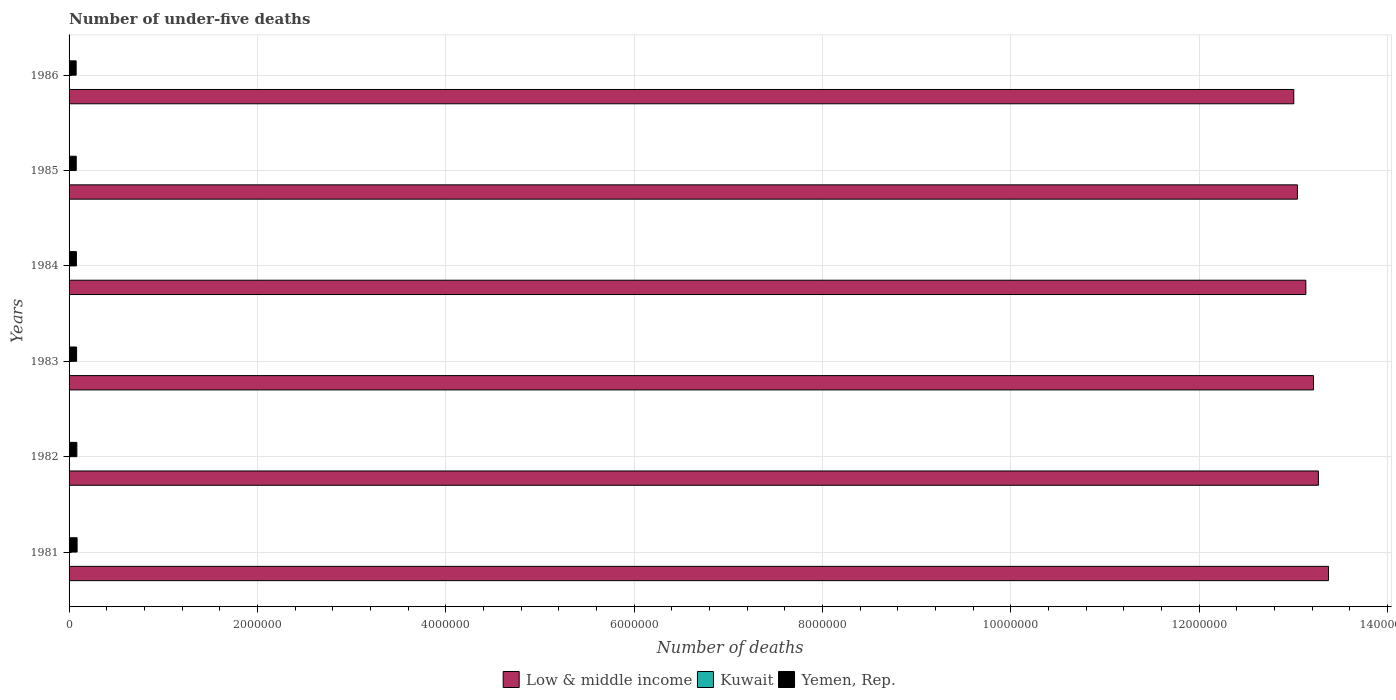How many groups of bars are there?
Make the answer very short. 6. Are the number of bars per tick equal to the number of legend labels?
Offer a terse response. Yes. How many bars are there on the 2nd tick from the top?
Offer a very short reply. 3. How many bars are there on the 1st tick from the bottom?
Your answer should be very brief. 3. In how many cases, is the number of bars for a given year not equal to the number of legend labels?
Your response must be concise. 0. What is the number of under-five deaths in Low & middle income in 1982?
Offer a very short reply. 1.33e+07. Across all years, what is the maximum number of under-five deaths in Kuwait?
Keep it short and to the point. 1573. Across all years, what is the minimum number of under-five deaths in Kuwait?
Give a very brief answer. 1160. What is the total number of under-five deaths in Yemen, Rep. in the graph?
Offer a very short reply. 4.77e+05. What is the difference between the number of under-five deaths in Low & middle income in 1983 and that in 1984?
Your answer should be compact. 8.14e+04. What is the difference between the number of under-five deaths in Yemen, Rep. in 1986 and the number of under-five deaths in Kuwait in 1984?
Provide a short and direct response. 7.38e+04. What is the average number of under-five deaths in Yemen, Rep. per year?
Keep it short and to the point. 7.95e+04. In the year 1983, what is the difference between the number of under-five deaths in Yemen, Rep. and number of under-five deaths in Low & middle income?
Your answer should be very brief. -1.31e+07. In how many years, is the number of under-five deaths in Kuwait greater than 2400000 ?
Your answer should be very brief. 0. What is the ratio of the number of under-five deaths in Kuwait in 1983 to that in 1985?
Offer a terse response. 1.13. Is the difference between the number of under-five deaths in Yemen, Rep. in 1982 and 1985 greater than the difference between the number of under-five deaths in Low & middle income in 1982 and 1985?
Your answer should be very brief. No. What is the difference between the highest and the second highest number of under-five deaths in Low & middle income?
Make the answer very short. 1.08e+05. What is the difference between the highest and the lowest number of under-five deaths in Low & middle income?
Keep it short and to the point. 3.69e+05. In how many years, is the number of under-five deaths in Kuwait greater than the average number of under-five deaths in Kuwait taken over all years?
Provide a short and direct response. 3. Is the sum of the number of under-five deaths in Kuwait in 1981 and 1982 greater than the maximum number of under-five deaths in Yemen, Rep. across all years?
Make the answer very short. No. What does the 3rd bar from the top in 1984 represents?
Your response must be concise. Low & middle income. What does the 1st bar from the bottom in 1981 represents?
Provide a short and direct response. Low & middle income. Is it the case that in every year, the sum of the number of under-five deaths in Low & middle income and number of under-five deaths in Kuwait is greater than the number of under-five deaths in Yemen, Rep.?
Make the answer very short. Yes. How many bars are there?
Your answer should be very brief. 18. Are all the bars in the graph horizontal?
Keep it short and to the point. Yes. How many years are there in the graph?
Your answer should be compact. 6. What is the difference between two consecutive major ticks on the X-axis?
Your answer should be compact. 2.00e+06. Are the values on the major ticks of X-axis written in scientific E-notation?
Your answer should be very brief. No. Does the graph contain any zero values?
Offer a very short reply. No. Where does the legend appear in the graph?
Keep it short and to the point. Bottom center. How many legend labels are there?
Provide a succinct answer. 3. What is the title of the graph?
Ensure brevity in your answer.  Number of under-five deaths. What is the label or title of the X-axis?
Provide a short and direct response. Number of deaths. What is the label or title of the Y-axis?
Give a very brief answer. Years. What is the Number of deaths in Low & middle income in 1981?
Ensure brevity in your answer.  1.34e+07. What is the Number of deaths in Kuwait in 1981?
Your answer should be very brief. 1573. What is the Number of deaths in Yemen, Rep. in 1981?
Provide a short and direct response. 8.51e+04. What is the Number of deaths of Low & middle income in 1982?
Provide a succinct answer. 1.33e+07. What is the Number of deaths in Kuwait in 1982?
Offer a very short reply. 1484. What is the Number of deaths of Yemen, Rep. in 1982?
Make the answer very short. 8.27e+04. What is the Number of deaths in Low & middle income in 1983?
Keep it short and to the point. 1.32e+07. What is the Number of deaths of Kuwait in 1983?
Your answer should be very brief. 1404. What is the Number of deaths in Yemen, Rep. in 1983?
Offer a terse response. 8.01e+04. What is the Number of deaths in Low & middle income in 1984?
Your answer should be very brief. 1.31e+07. What is the Number of deaths of Kuwait in 1984?
Offer a very short reply. 1323. What is the Number of deaths in Yemen, Rep. in 1984?
Provide a short and direct response. 7.79e+04. What is the Number of deaths in Low & middle income in 1985?
Offer a very short reply. 1.30e+07. What is the Number of deaths in Kuwait in 1985?
Provide a succinct answer. 1239. What is the Number of deaths in Yemen, Rep. in 1985?
Your response must be concise. 7.63e+04. What is the Number of deaths of Low & middle income in 1986?
Provide a short and direct response. 1.30e+07. What is the Number of deaths of Kuwait in 1986?
Give a very brief answer. 1160. What is the Number of deaths in Yemen, Rep. in 1986?
Make the answer very short. 7.51e+04. Across all years, what is the maximum Number of deaths in Low & middle income?
Offer a terse response. 1.34e+07. Across all years, what is the maximum Number of deaths of Kuwait?
Your answer should be compact. 1573. Across all years, what is the maximum Number of deaths of Yemen, Rep.?
Your response must be concise. 8.51e+04. Across all years, what is the minimum Number of deaths of Low & middle income?
Provide a short and direct response. 1.30e+07. Across all years, what is the minimum Number of deaths in Kuwait?
Make the answer very short. 1160. Across all years, what is the minimum Number of deaths in Yemen, Rep.?
Provide a short and direct response. 7.51e+04. What is the total Number of deaths of Low & middle income in the graph?
Your answer should be very brief. 7.90e+07. What is the total Number of deaths in Kuwait in the graph?
Give a very brief answer. 8183. What is the total Number of deaths in Yemen, Rep. in the graph?
Give a very brief answer. 4.77e+05. What is the difference between the Number of deaths of Low & middle income in 1981 and that in 1982?
Ensure brevity in your answer.  1.08e+05. What is the difference between the Number of deaths in Kuwait in 1981 and that in 1982?
Your response must be concise. 89. What is the difference between the Number of deaths of Yemen, Rep. in 1981 and that in 1982?
Give a very brief answer. 2482. What is the difference between the Number of deaths of Low & middle income in 1981 and that in 1983?
Make the answer very short. 1.59e+05. What is the difference between the Number of deaths in Kuwait in 1981 and that in 1983?
Offer a terse response. 169. What is the difference between the Number of deaths of Yemen, Rep. in 1981 and that in 1983?
Make the answer very short. 5046. What is the difference between the Number of deaths in Low & middle income in 1981 and that in 1984?
Make the answer very short. 2.41e+05. What is the difference between the Number of deaths in Kuwait in 1981 and that in 1984?
Your answer should be very brief. 250. What is the difference between the Number of deaths of Yemen, Rep. in 1981 and that in 1984?
Your response must be concise. 7245. What is the difference between the Number of deaths in Low & middle income in 1981 and that in 1985?
Offer a very short reply. 3.30e+05. What is the difference between the Number of deaths in Kuwait in 1981 and that in 1985?
Provide a succinct answer. 334. What is the difference between the Number of deaths in Yemen, Rep. in 1981 and that in 1985?
Make the answer very short. 8877. What is the difference between the Number of deaths of Low & middle income in 1981 and that in 1986?
Offer a very short reply. 3.69e+05. What is the difference between the Number of deaths of Kuwait in 1981 and that in 1986?
Your answer should be very brief. 413. What is the difference between the Number of deaths of Yemen, Rep. in 1981 and that in 1986?
Ensure brevity in your answer.  1.00e+04. What is the difference between the Number of deaths in Low & middle income in 1982 and that in 1983?
Ensure brevity in your answer.  5.17e+04. What is the difference between the Number of deaths of Yemen, Rep. in 1982 and that in 1983?
Your answer should be compact. 2564. What is the difference between the Number of deaths of Low & middle income in 1982 and that in 1984?
Offer a very short reply. 1.33e+05. What is the difference between the Number of deaths in Kuwait in 1982 and that in 1984?
Your answer should be compact. 161. What is the difference between the Number of deaths in Yemen, Rep. in 1982 and that in 1984?
Provide a short and direct response. 4763. What is the difference between the Number of deaths of Low & middle income in 1982 and that in 1985?
Offer a terse response. 2.23e+05. What is the difference between the Number of deaths in Kuwait in 1982 and that in 1985?
Provide a short and direct response. 245. What is the difference between the Number of deaths of Yemen, Rep. in 1982 and that in 1985?
Offer a terse response. 6395. What is the difference between the Number of deaths in Low & middle income in 1982 and that in 1986?
Give a very brief answer. 2.61e+05. What is the difference between the Number of deaths in Kuwait in 1982 and that in 1986?
Your response must be concise. 324. What is the difference between the Number of deaths in Yemen, Rep. in 1982 and that in 1986?
Ensure brevity in your answer.  7550. What is the difference between the Number of deaths in Low & middle income in 1983 and that in 1984?
Offer a terse response. 8.14e+04. What is the difference between the Number of deaths in Yemen, Rep. in 1983 and that in 1984?
Your answer should be very brief. 2199. What is the difference between the Number of deaths of Low & middle income in 1983 and that in 1985?
Your answer should be very brief. 1.71e+05. What is the difference between the Number of deaths in Kuwait in 1983 and that in 1985?
Give a very brief answer. 165. What is the difference between the Number of deaths in Yemen, Rep. in 1983 and that in 1985?
Provide a short and direct response. 3831. What is the difference between the Number of deaths in Low & middle income in 1983 and that in 1986?
Your answer should be compact. 2.09e+05. What is the difference between the Number of deaths of Kuwait in 1983 and that in 1986?
Offer a terse response. 244. What is the difference between the Number of deaths in Yemen, Rep. in 1983 and that in 1986?
Keep it short and to the point. 4986. What is the difference between the Number of deaths of Low & middle income in 1984 and that in 1985?
Keep it short and to the point. 8.95e+04. What is the difference between the Number of deaths in Yemen, Rep. in 1984 and that in 1985?
Give a very brief answer. 1632. What is the difference between the Number of deaths of Low & middle income in 1984 and that in 1986?
Provide a succinct answer. 1.28e+05. What is the difference between the Number of deaths of Kuwait in 1984 and that in 1986?
Provide a succinct answer. 163. What is the difference between the Number of deaths of Yemen, Rep. in 1984 and that in 1986?
Make the answer very short. 2787. What is the difference between the Number of deaths in Low & middle income in 1985 and that in 1986?
Your answer should be very brief. 3.86e+04. What is the difference between the Number of deaths in Kuwait in 1985 and that in 1986?
Provide a succinct answer. 79. What is the difference between the Number of deaths in Yemen, Rep. in 1985 and that in 1986?
Give a very brief answer. 1155. What is the difference between the Number of deaths in Low & middle income in 1981 and the Number of deaths in Kuwait in 1982?
Your answer should be very brief. 1.34e+07. What is the difference between the Number of deaths in Low & middle income in 1981 and the Number of deaths in Yemen, Rep. in 1982?
Offer a very short reply. 1.33e+07. What is the difference between the Number of deaths of Kuwait in 1981 and the Number of deaths of Yemen, Rep. in 1982?
Offer a terse response. -8.11e+04. What is the difference between the Number of deaths of Low & middle income in 1981 and the Number of deaths of Kuwait in 1983?
Make the answer very short. 1.34e+07. What is the difference between the Number of deaths of Low & middle income in 1981 and the Number of deaths of Yemen, Rep. in 1983?
Keep it short and to the point. 1.33e+07. What is the difference between the Number of deaths in Kuwait in 1981 and the Number of deaths in Yemen, Rep. in 1983?
Ensure brevity in your answer.  -7.85e+04. What is the difference between the Number of deaths of Low & middle income in 1981 and the Number of deaths of Kuwait in 1984?
Keep it short and to the point. 1.34e+07. What is the difference between the Number of deaths in Low & middle income in 1981 and the Number of deaths in Yemen, Rep. in 1984?
Give a very brief answer. 1.33e+07. What is the difference between the Number of deaths of Kuwait in 1981 and the Number of deaths of Yemen, Rep. in 1984?
Your response must be concise. -7.63e+04. What is the difference between the Number of deaths in Low & middle income in 1981 and the Number of deaths in Kuwait in 1985?
Your answer should be very brief. 1.34e+07. What is the difference between the Number of deaths of Low & middle income in 1981 and the Number of deaths of Yemen, Rep. in 1985?
Your answer should be compact. 1.33e+07. What is the difference between the Number of deaths in Kuwait in 1981 and the Number of deaths in Yemen, Rep. in 1985?
Provide a succinct answer. -7.47e+04. What is the difference between the Number of deaths of Low & middle income in 1981 and the Number of deaths of Kuwait in 1986?
Give a very brief answer. 1.34e+07. What is the difference between the Number of deaths in Low & middle income in 1981 and the Number of deaths in Yemen, Rep. in 1986?
Ensure brevity in your answer.  1.33e+07. What is the difference between the Number of deaths of Kuwait in 1981 and the Number of deaths of Yemen, Rep. in 1986?
Your answer should be compact. -7.35e+04. What is the difference between the Number of deaths of Low & middle income in 1982 and the Number of deaths of Kuwait in 1983?
Your response must be concise. 1.33e+07. What is the difference between the Number of deaths of Low & middle income in 1982 and the Number of deaths of Yemen, Rep. in 1983?
Provide a succinct answer. 1.32e+07. What is the difference between the Number of deaths of Kuwait in 1982 and the Number of deaths of Yemen, Rep. in 1983?
Your answer should be compact. -7.86e+04. What is the difference between the Number of deaths in Low & middle income in 1982 and the Number of deaths in Kuwait in 1984?
Your answer should be compact. 1.33e+07. What is the difference between the Number of deaths in Low & middle income in 1982 and the Number of deaths in Yemen, Rep. in 1984?
Offer a terse response. 1.32e+07. What is the difference between the Number of deaths in Kuwait in 1982 and the Number of deaths in Yemen, Rep. in 1984?
Ensure brevity in your answer.  -7.64e+04. What is the difference between the Number of deaths of Low & middle income in 1982 and the Number of deaths of Kuwait in 1985?
Keep it short and to the point. 1.33e+07. What is the difference between the Number of deaths in Low & middle income in 1982 and the Number of deaths in Yemen, Rep. in 1985?
Offer a very short reply. 1.32e+07. What is the difference between the Number of deaths in Kuwait in 1982 and the Number of deaths in Yemen, Rep. in 1985?
Your answer should be very brief. -7.48e+04. What is the difference between the Number of deaths of Low & middle income in 1982 and the Number of deaths of Kuwait in 1986?
Your response must be concise. 1.33e+07. What is the difference between the Number of deaths in Low & middle income in 1982 and the Number of deaths in Yemen, Rep. in 1986?
Provide a succinct answer. 1.32e+07. What is the difference between the Number of deaths in Kuwait in 1982 and the Number of deaths in Yemen, Rep. in 1986?
Your answer should be compact. -7.36e+04. What is the difference between the Number of deaths of Low & middle income in 1983 and the Number of deaths of Kuwait in 1984?
Provide a succinct answer. 1.32e+07. What is the difference between the Number of deaths of Low & middle income in 1983 and the Number of deaths of Yemen, Rep. in 1984?
Your answer should be very brief. 1.31e+07. What is the difference between the Number of deaths of Kuwait in 1983 and the Number of deaths of Yemen, Rep. in 1984?
Make the answer very short. -7.65e+04. What is the difference between the Number of deaths in Low & middle income in 1983 and the Number of deaths in Kuwait in 1985?
Your response must be concise. 1.32e+07. What is the difference between the Number of deaths of Low & middle income in 1983 and the Number of deaths of Yemen, Rep. in 1985?
Make the answer very short. 1.31e+07. What is the difference between the Number of deaths of Kuwait in 1983 and the Number of deaths of Yemen, Rep. in 1985?
Ensure brevity in your answer.  -7.49e+04. What is the difference between the Number of deaths of Low & middle income in 1983 and the Number of deaths of Kuwait in 1986?
Your answer should be very brief. 1.32e+07. What is the difference between the Number of deaths of Low & middle income in 1983 and the Number of deaths of Yemen, Rep. in 1986?
Give a very brief answer. 1.31e+07. What is the difference between the Number of deaths of Kuwait in 1983 and the Number of deaths of Yemen, Rep. in 1986?
Make the answer very short. -7.37e+04. What is the difference between the Number of deaths in Low & middle income in 1984 and the Number of deaths in Kuwait in 1985?
Give a very brief answer. 1.31e+07. What is the difference between the Number of deaths in Low & middle income in 1984 and the Number of deaths in Yemen, Rep. in 1985?
Provide a short and direct response. 1.31e+07. What is the difference between the Number of deaths of Kuwait in 1984 and the Number of deaths of Yemen, Rep. in 1985?
Make the answer very short. -7.49e+04. What is the difference between the Number of deaths in Low & middle income in 1984 and the Number of deaths in Kuwait in 1986?
Your answer should be compact. 1.31e+07. What is the difference between the Number of deaths in Low & middle income in 1984 and the Number of deaths in Yemen, Rep. in 1986?
Offer a very short reply. 1.31e+07. What is the difference between the Number of deaths in Kuwait in 1984 and the Number of deaths in Yemen, Rep. in 1986?
Ensure brevity in your answer.  -7.38e+04. What is the difference between the Number of deaths in Low & middle income in 1985 and the Number of deaths in Kuwait in 1986?
Ensure brevity in your answer.  1.30e+07. What is the difference between the Number of deaths in Low & middle income in 1985 and the Number of deaths in Yemen, Rep. in 1986?
Ensure brevity in your answer.  1.30e+07. What is the difference between the Number of deaths of Kuwait in 1985 and the Number of deaths of Yemen, Rep. in 1986?
Ensure brevity in your answer.  -7.39e+04. What is the average Number of deaths in Low & middle income per year?
Your answer should be compact. 1.32e+07. What is the average Number of deaths of Kuwait per year?
Your answer should be very brief. 1363.83. What is the average Number of deaths in Yemen, Rep. per year?
Make the answer very short. 7.95e+04. In the year 1981, what is the difference between the Number of deaths of Low & middle income and Number of deaths of Kuwait?
Offer a terse response. 1.34e+07. In the year 1981, what is the difference between the Number of deaths in Low & middle income and Number of deaths in Yemen, Rep.?
Your answer should be very brief. 1.33e+07. In the year 1981, what is the difference between the Number of deaths in Kuwait and Number of deaths in Yemen, Rep.?
Provide a short and direct response. -8.36e+04. In the year 1982, what is the difference between the Number of deaths of Low & middle income and Number of deaths of Kuwait?
Your answer should be very brief. 1.33e+07. In the year 1982, what is the difference between the Number of deaths of Low & middle income and Number of deaths of Yemen, Rep.?
Ensure brevity in your answer.  1.32e+07. In the year 1982, what is the difference between the Number of deaths in Kuwait and Number of deaths in Yemen, Rep.?
Provide a succinct answer. -8.12e+04. In the year 1983, what is the difference between the Number of deaths in Low & middle income and Number of deaths in Kuwait?
Your response must be concise. 1.32e+07. In the year 1983, what is the difference between the Number of deaths in Low & middle income and Number of deaths in Yemen, Rep.?
Your response must be concise. 1.31e+07. In the year 1983, what is the difference between the Number of deaths of Kuwait and Number of deaths of Yemen, Rep.?
Ensure brevity in your answer.  -7.87e+04. In the year 1984, what is the difference between the Number of deaths of Low & middle income and Number of deaths of Kuwait?
Make the answer very short. 1.31e+07. In the year 1984, what is the difference between the Number of deaths of Low & middle income and Number of deaths of Yemen, Rep.?
Offer a terse response. 1.31e+07. In the year 1984, what is the difference between the Number of deaths of Kuwait and Number of deaths of Yemen, Rep.?
Offer a terse response. -7.66e+04. In the year 1985, what is the difference between the Number of deaths of Low & middle income and Number of deaths of Kuwait?
Your answer should be very brief. 1.30e+07. In the year 1985, what is the difference between the Number of deaths of Low & middle income and Number of deaths of Yemen, Rep.?
Ensure brevity in your answer.  1.30e+07. In the year 1985, what is the difference between the Number of deaths in Kuwait and Number of deaths in Yemen, Rep.?
Provide a succinct answer. -7.50e+04. In the year 1986, what is the difference between the Number of deaths in Low & middle income and Number of deaths in Kuwait?
Provide a short and direct response. 1.30e+07. In the year 1986, what is the difference between the Number of deaths of Low & middle income and Number of deaths of Yemen, Rep.?
Your response must be concise. 1.29e+07. In the year 1986, what is the difference between the Number of deaths in Kuwait and Number of deaths in Yemen, Rep.?
Provide a succinct answer. -7.39e+04. What is the ratio of the Number of deaths in Kuwait in 1981 to that in 1982?
Offer a very short reply. 1.06. What is the ratio of the Number of deaths of Low & middle income in 1981 to that in 1983?
Your response must be concise. 1.01. What is the ratio of the Number of deaths of Kuwait in 1981 to that in 1983?
Make the answer very short. 1.12. What is the ratio of the Number of deaths in Yemen, Rep. in 1981 to that in 1983?
Ensure brevity in your answer.  1.06. What is the ratio of the Number of deaths of Low & middle income in 1981 to that in 1984?
Provide a succinct answer. 1.02. What is the ratio of the Number of deaths of Kuwait in 1981 to that in 1984?
Your answer should be compact. 1.19. What is the ratio of the Number of deaths in Yemen, Rep. in 1981 to that in 1984?
Provide a succinct answer. 1.09. What is the ratio of the Number of deaths of Low & middle income in 1981 to that in 1985?
Your answer should be compact. 1.03. What is the ratio of the Number of deaths in Kuwait in 1981 to that in 1985?
Your answer should be compact. 1.27. What is the ratio of the Number of deaths in Yemen, Rep. in 1981 to that in 1985?
Your response must be concise. 1.12. What is the ratio of the Number of deaths in Low & middle income in 1981 to that in 1986?
Keep it short and to the point. 1.03. What is the ratio of the Number of deaths in Kuwait in 1981 to that in 1986?
Make the answer very short. 1.36. What is the ratio of the Number of deaths in Yemen, Rep. in 1981 to that in 1986?
Offer a terse response. 1.13. What is the ratio of the Number of deaths in Kuwait in 1982 to that in 1983?
Ensure brevity in your answer.  1.06. What is the ratio of the Number of deaths of Yemen, Rep. in 1982 to that in 1983?
Make the answer very short. 1.03. What is the ratio of the Number of deaths of Kuwait in 1982 to that in 1984?
Offer a terse response. 1.12. What is the ratio of the Number of deaths of Yemen, Rep. in 1982 to that in 1984?
Offer a very short reply. 1.06. What is the ratio of the Number of deaths of Low & middle income in 1982 to that in 1985?
Provide a succinct answer. 1.02. What is the ratio of the Number of deaths in Kuwait in 1982 to that in 1985?
Make the answer very short. 1.2. What is the ratio of the Number of deaths of Yemen, Rep. in 1982 to that in 1985?
Your response must be concise. 1.08. What is the ratio of the Number of deaths in Low & middle income in 1982 to that in 1986?
Make the answer very short. 1.02. What is the ratio of the Number of deaths of Kuwait in 1982 to that in 1986?
Ensure brevity in your answer.  1.28. What is the ratio of the Number of deaths of Yemen, Rep. in 1982 to that in 1986?
Provide a succinct answer. 1.1. What is the ratio of the Number of deaths of Low & middle income in 1983 to that in 1984?
Your answer should be very brief. 1.01. What is the ratio of the Number of deaths in Kuwait in 1983 to that in 1984?
Make the answer very short. 1.06. What is the ratio of the Number of deaths in Yemen, Rep. in 1983 to that in 1984?
Your response must be concise. 1.03. What is the ratio of the Number of deaths in Low & middle income in 1983 to that in 1985?
Keep it short and to the point. 1.01. What is the ratio of the Number of deaths in Kuwait in 1983 to that in 1985?
Your answer should be compact. 1.13. What is the ratio of the Number of deaths in Yemen, Rep. in 1983 to that in 1985?
Offer a very short reply. 1.05. What is the ratio of the Number of deaths in Low & middle income in 1983 to that in 1986?
Provide a short and direct response. 1.02. What is the ratio of the Number of deaths of Kuwait in 1983 to that in 1986?
Your response must be concise. 1.21. What is the ratio of the Number of deaths in Yemen, Rep. in 1983 to that in 1986?
Make the answer very short. 1.07. What is the ratio of the Number of deaths in Low & middle income in 1984 to that in 1985?
Your response must be concise. 1.01. What is the ratio of the Number of deaths of Kuwait in 1984 to that in 1985?
Offer a terse response. 1.07. What is the ratio of the Number of deaths of Yemen, Rep. in 1984 to that in 1985?
Provide a short and direct response. 1.02. What is the ratio of the Number of deaths in Low & middle income in 1984 to that in 1986?
Your answer should be compact. 1.01. What is the ratio of the Number of deaths of Kuwait in 1984 to that in 1986?
Your response must be concise. 1.14. What is the ratio of the Number of deaths of Yemen, Rep. in 1984 to that in 1986?
Your response must be concise. 1.04. What is the ratio of the Number of deaths in Low & middle income in 1985 to that in 1986?
Offer a very short reply. 1. What is the ratio of the Number of deaths of Kuwait in 1985 to that in 1986?
Ensure brevity in your answer.  1.07. What is the ratio of the Number of deaths of Yemen, Rep. in 1985 to that in 1986?
Keep it short and to the point. 1.02. What is the difference between the highest and the second highest Number of deaths of Low & middle income?
Provide a short and direct response. 1.08e+05. What is the difference between the highest and the second highest Number of deaths of Kuwait?
Make the answer very short. 89. What is the difference between the highest and the second highest Number of deaths in Yemen, Rep.?
Provide a succinct answer. 2482. What is the difference between the highest and the lowest Number of deaths in Low & middle income?
Ensure brevity in your answer.  3.69e+05. What is the difference between the highest and the lowest Number of deaths of Kuwait?
Offer a terse response. 413. What is the difference between the highest and the lowest Number of deaths of Yemen, Rep.?
Your answer should be compact. 1.00e+04. 